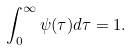<formula> <loc_0><loc_0><loc_500><loc_500>\int _ { 0 } ^ { \infty } \psi { ( \tau ) } d \tau = 1 .</formula> 